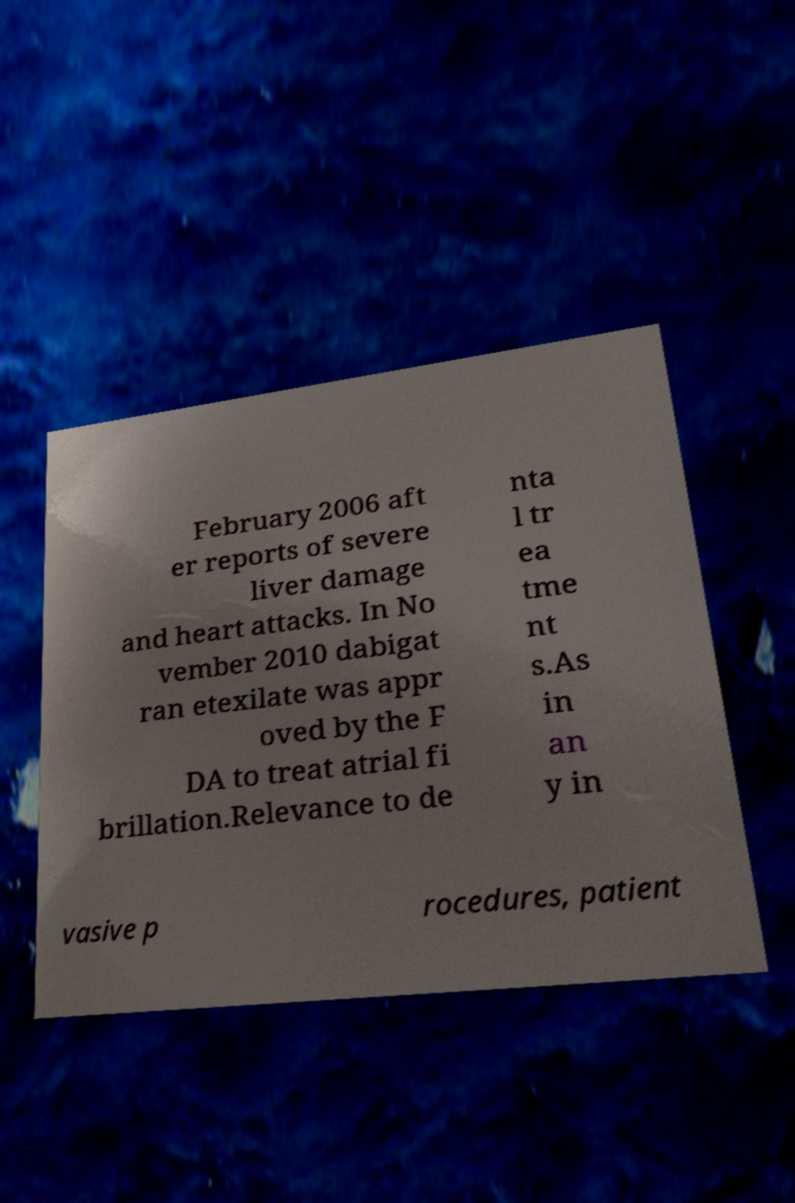There's text embedded in this image that I need extracted. Can you transcribe it verbatim? February 2006 aft er reports of severe liver damage and heart attacks. In No vember 2010 dabigat ran etexilate was appr oved by the F DA to treat atrial fi brillation.Relevance to de nta l tr ea tme nt s.As in an y in vasive p rocedures, patient 